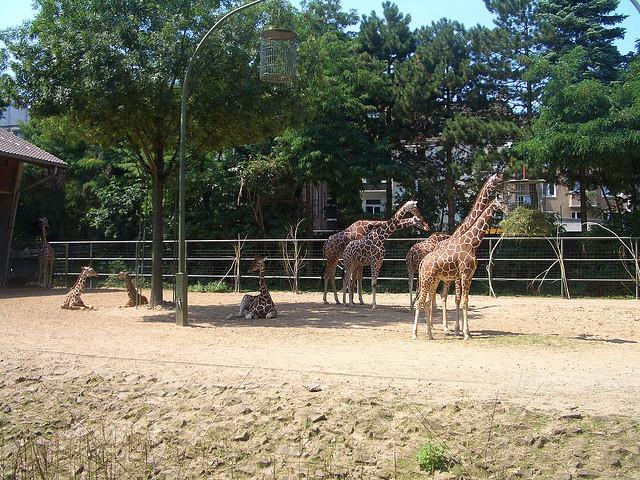What animals can be seen?

Choices:
A) cows
B) antelopes
C) giraffes
D) horses giraffes 